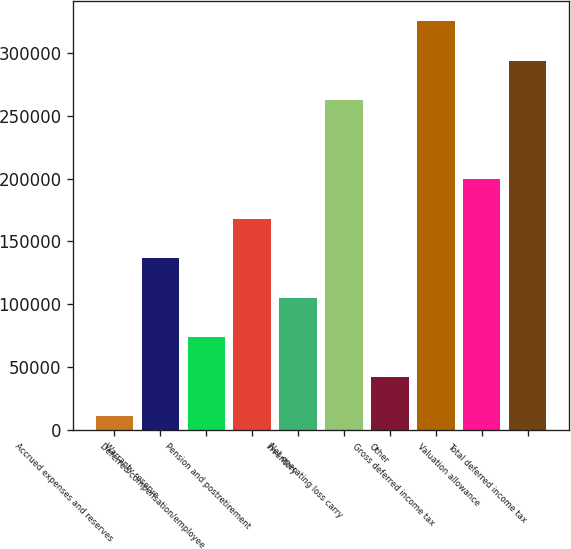Convert chart to OTSL. <chart><loc_0><loc_0><loc_500><loc_500><bar_chart><fcel>Accrued expenses and reserves<fcel>Warranty reserve<fcel>Deferred compensation/employee<fcel>Pension and postretirement<fcel>Inventory<fcel>Net operating loss carry<fcel>Other<fcel>Gross deferred income tax<fcel>Valuation allowance<fcel>Total deferred income tax<nl><fcel>10961<fcel>136639<fcel>73800<fcel>168058<fcel>105220<fcel>262317<fcel>42380.5<fcel>325156<fcel>199478<fcel>293736<nl></chart> 